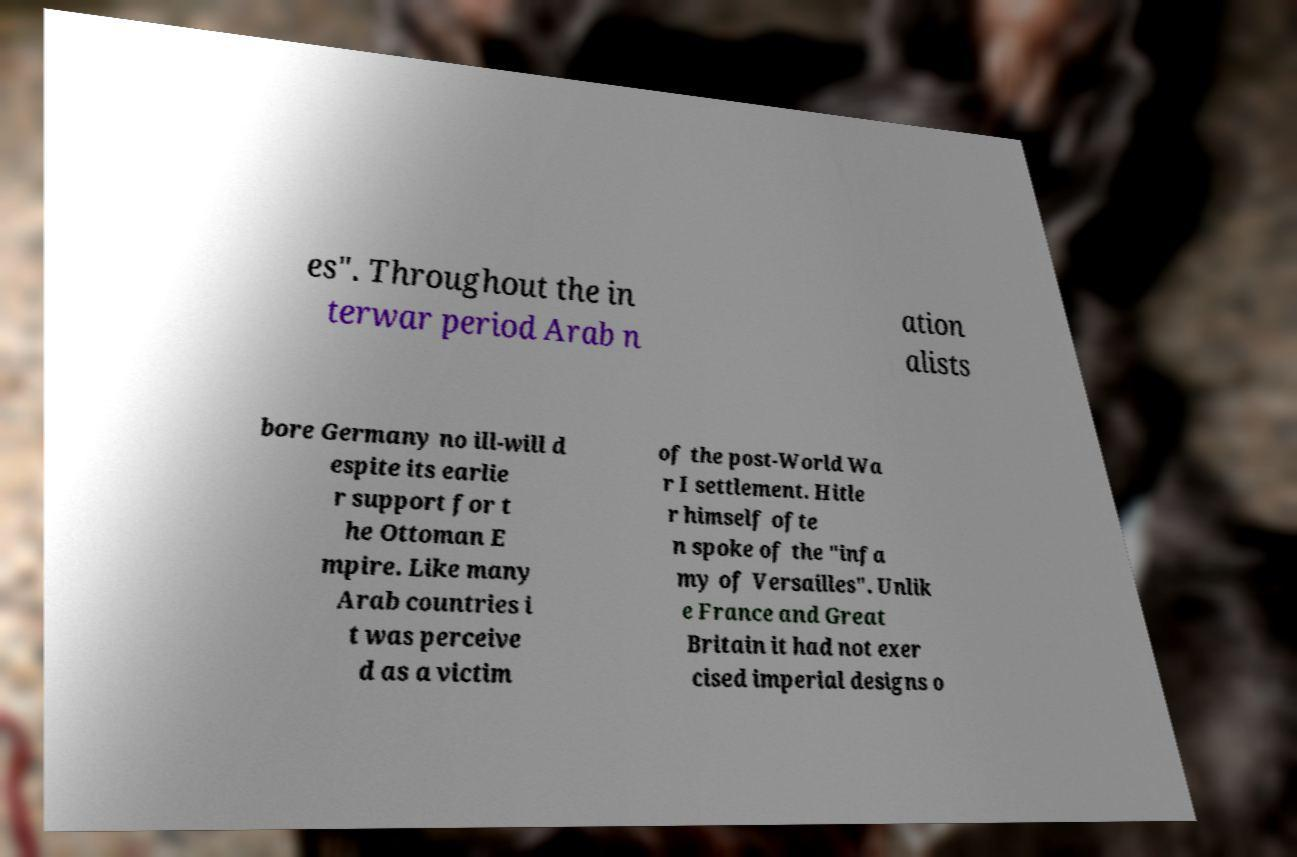Could you extract and type out the text from this image? es". Throughout the in terwar period Arab n ation alists bore Germany no ill-will d espite its earlie r support for t he Ottoman E mpire. Like many Arab countries i t was perceive d as a victim of the post-World Wa r I settlement. Hitle r himself ofte n spoke of the "infa my of Versailles". Unlik e France and Great Britain it had not exer cised imperial designs o 